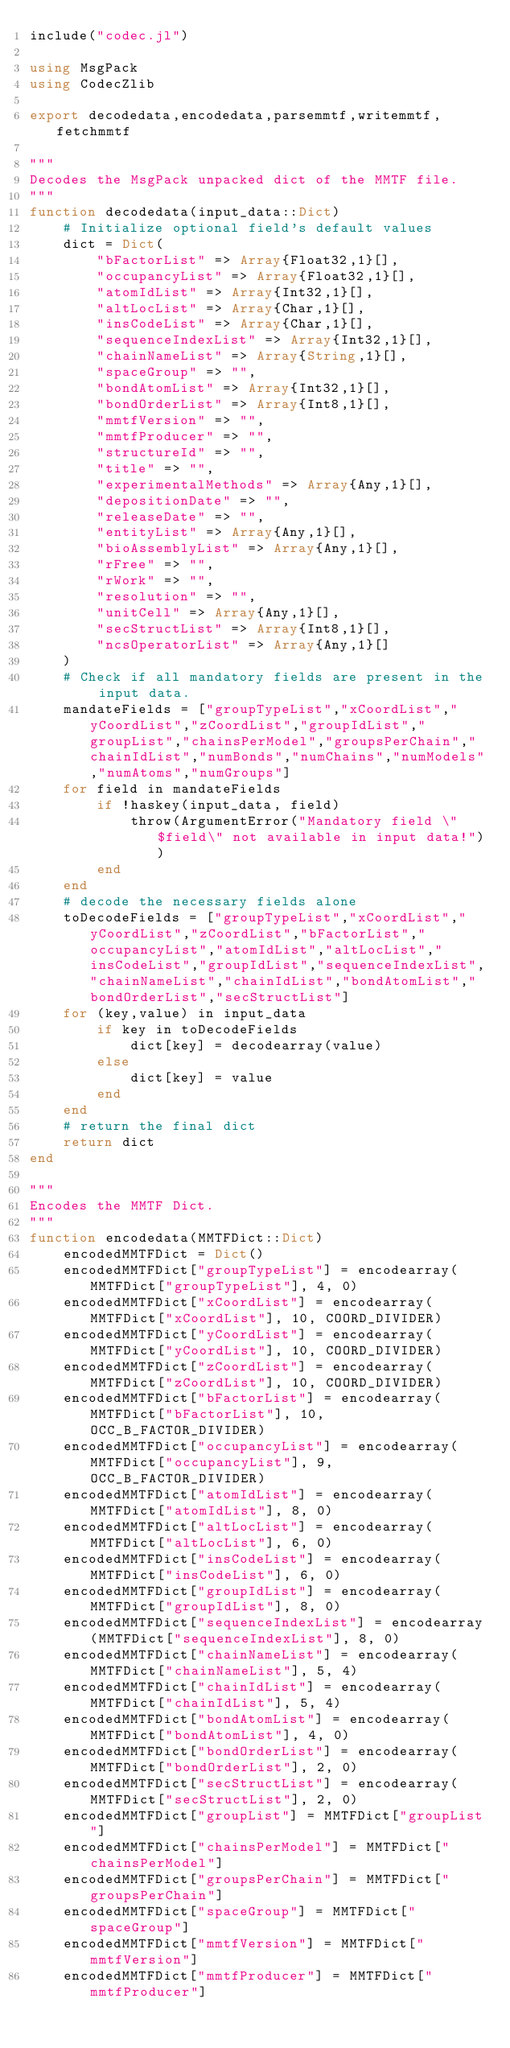<code> <loc_0><loc_0><loc_500><loc_500><_Julia_>include("codec.jl")

using MsgPack
using CodecZlib

export decodedata,encodedata,parsemmtf,writemmtf,fetchmmtf

"""
Decodes the MsgPack unpacked dict of the MMTF file.
"""
function decodedata(input_data::Dict)
    # Initialize optional field's default values
    dict = Dict(
        "bFactorList" => Array{Float32,1}[],
        "occupancyList" => Array{Float32,1}[],
        "atomIdList" => Array{Int32,1}[],
        "altLocList" => Array{Char,1}[],
        "insCodeList" => Array{Char,1}[],
        "sequenceIndexList" => Array{Int32,1}[],
        "chainNameList" => Array{String,1}[],
        "spaceGroup" => "",
        "bondAtomList" => Array{Int32,1}[],
        "bondOrderList" => Array{Int8,1}[],
        "mmtfVersion" => "",
        "mmtfProducer" => "",
        "structureId" => "",
        "title" => "",
        "experimentalMethods" => Array{Any,1}[],
        "depositionDate" => "",
        "releaseDate" => "",
        "entityList" => Array{Any,1}[],
        "bioAssemblyList" => Array{Any,1}[],
        "rFree" => "",
        "rWork" => "",
        "resolution" => "",
        "unitCell" => Array{Any,1}[],
        "secStructList" => Array{Int8,1}[],
        "ncsOperatorList" => Array{Any,1}[]
    )
    # Check if all mandatory fields are present in the input data.
    mandateFields = ["groupTypeList","xCoordList","yCoordList","zCoordList","groupIdList","groupList","chainsPerModel","groupsPerChain","chainIdList","numBonds","numChains","numModels","numAtoms","numGroups"]
    for field in mandateFields
        if !haskey(input_data, field)
            throw(ArgumentError("Mandatory field \"$field\" not available in input data!"))
        end    
    end
    # decode the necessary fields alone
    toDecodeFields = ["groupTypeList","xCoordList","yCoordList","zCoordList","bFactorList","occupancyList","atomIdList","altLocList","insCodeList","groupIdList","sequenceIndexList","chainNameList","chainIdList","bondAtomList","bondOrderList","secStructList"]
    for (key,value) in input_data
        if key in toDecodeFields
            dict[key] = decodearray(value)
        else    
            dict[key] = value
        end
    end
    # return the final dict
    return dict
end

"""
Encodes the MMTF Dict.
"""
function encodedata(MMTFDict::Dict)
    encodedMMTFDict = Dict()
    encodedMMTFDict["groupTypeList"] = encodearray(MMTFDict["groupTypeList"], 4, 0)
    encodedMMTFDict["xCoordList"] = encodearray(MMTFDict["xCoordList"], 10, COORD_DIVIDER)
    encodedMMTFDict["yCoordList"] = encodearray(MMTFDict["yCoordList"], 10, COORD_DIVIDER)
    encodedMMTFDict["zCoordList"] = encodearray(MMTFDict["zCoordList"], 10, COORD_DIVIDER)
    encodedMMTFDict["bFactorList"] = encodearray(MMTFDict["bFactorList"], 10, OCC_B_FACTOR_DIVIDER)
    encodedMMTFDict["occupancyList"] = encodearray(MMTFDict["occupancyList"], 9, OCC_B_FACTOR_DIVIDER)
    encodedMMTFDict["atomIdList"] = encodearray(MMTFDict["atomIdList"], 8, 0)
    encodedMMTFDict["altLocList"] = encodearray(MMTFDict["altLocList"], 6, 0)
    encodedMMTFDict["insCodeList"] = encodearray(MMTFDict["insCodeList"], 6, 0)
    encodedMMTFDict["groupIdList"] = encodearray(MMTFDict["groupIdList"], 8, 0)
    encodedMMTFDict["sequenceIndexList"] = encodearray(MMTFDict["sequenceIndexList"], 8, 0)
    encodedMMTFDict["chainNameList"] = encodearray(MMTFDict["chainNameList"], 5, 4)
    encodedMMTFDict["chainIdList"] = encodearray(MMTFDict["chainIdList"], 5, 4)
    encodedMMTFDict["bondAtomList"] = encodearray(MMTFDict["bondAtomList"], 4, 0)
    encodedMMTFDict["bondOrderList"] = encodearray(MMTFDict["bondOrderList"], 2, 0)
    encodedMMTFDict["secStructList"] = encodearray(MMTFDict["secStructList"], 2, 0)
    encodedMMTFDict["groupList"] = MMTFDict["groupList"]
    encodedMMTFDict["chainsPerModel"] = MMTFDict["chainsPerModel"]
    encodedMMTFDict["groupsPerChain"] = MMTFDict["groupsPerChain"]
    encodedMMTFDict["spaceGroup"] = MMTFDict["spaceGroup"]
    encodedMMTFDict["mmtfVersion"] = MMTFDict["mmtfVersion"]
    encodedMMTFDict["mmtfProducer"] = MMTFDict["mmtfProducer"]</code> 